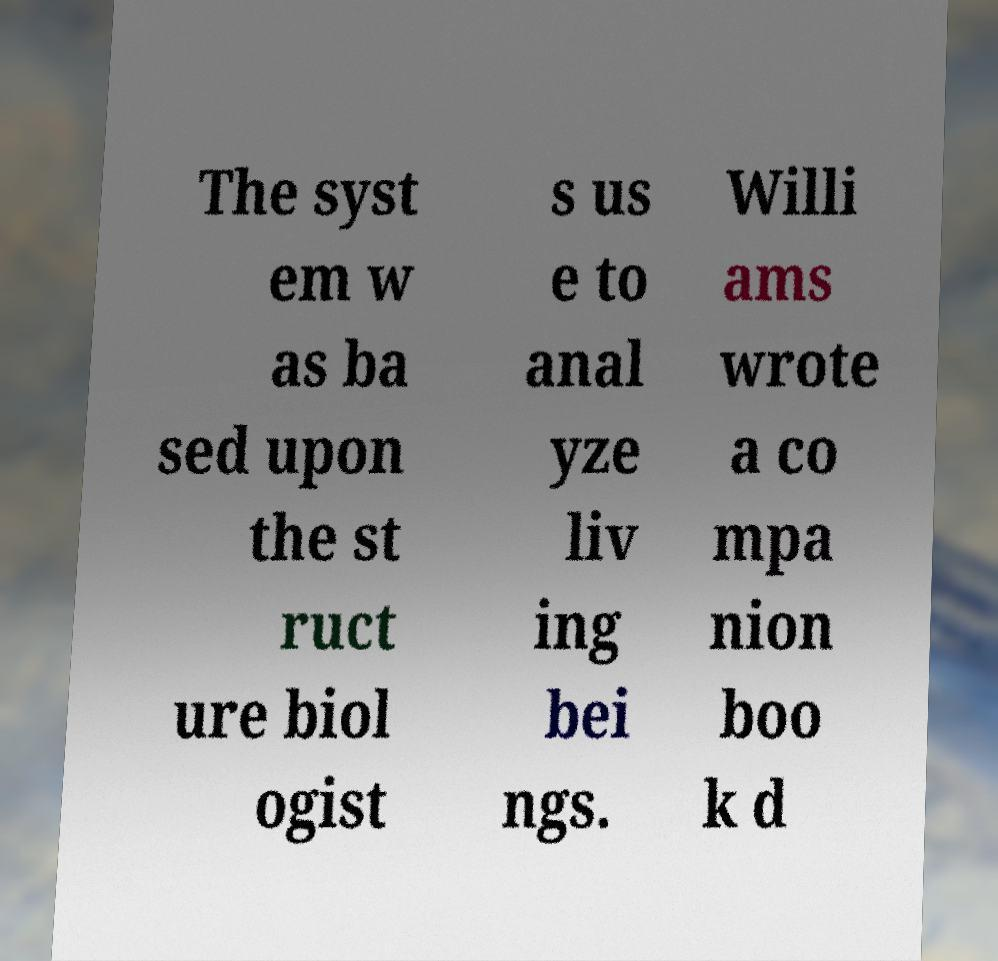Can you accurately transcribe the text from the provided image for me? The syst em w as ba sed upon the st ruct ure biol ogist s us e to anal yze liv ing bei ngs. Willi ams wrote a co mpa nion boo k d 